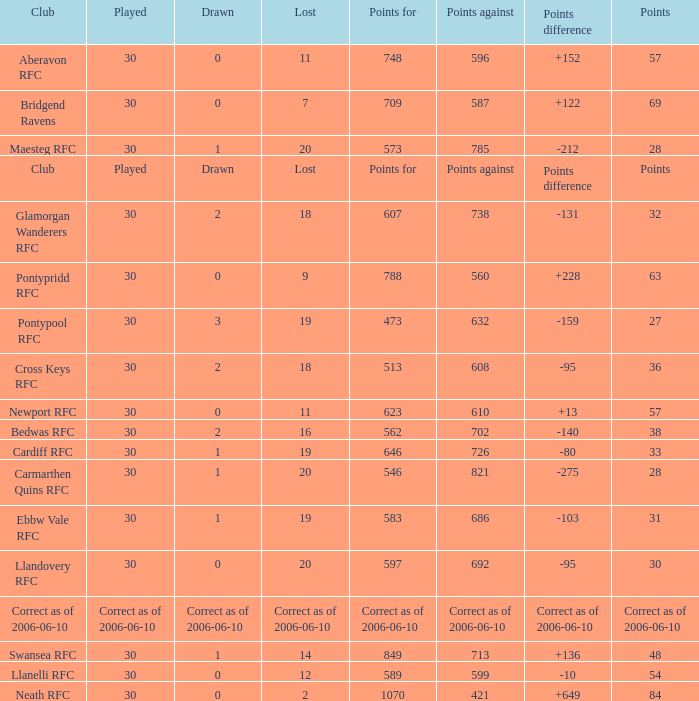What is Points For, when Points is "63"? 788.0. 